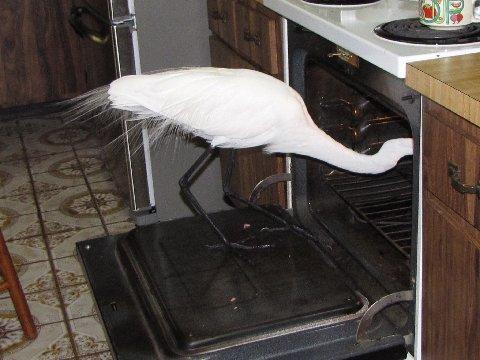Does the caption "The bird is touching the oven." correctly depict the image?
Answer yes or no. Yes. 